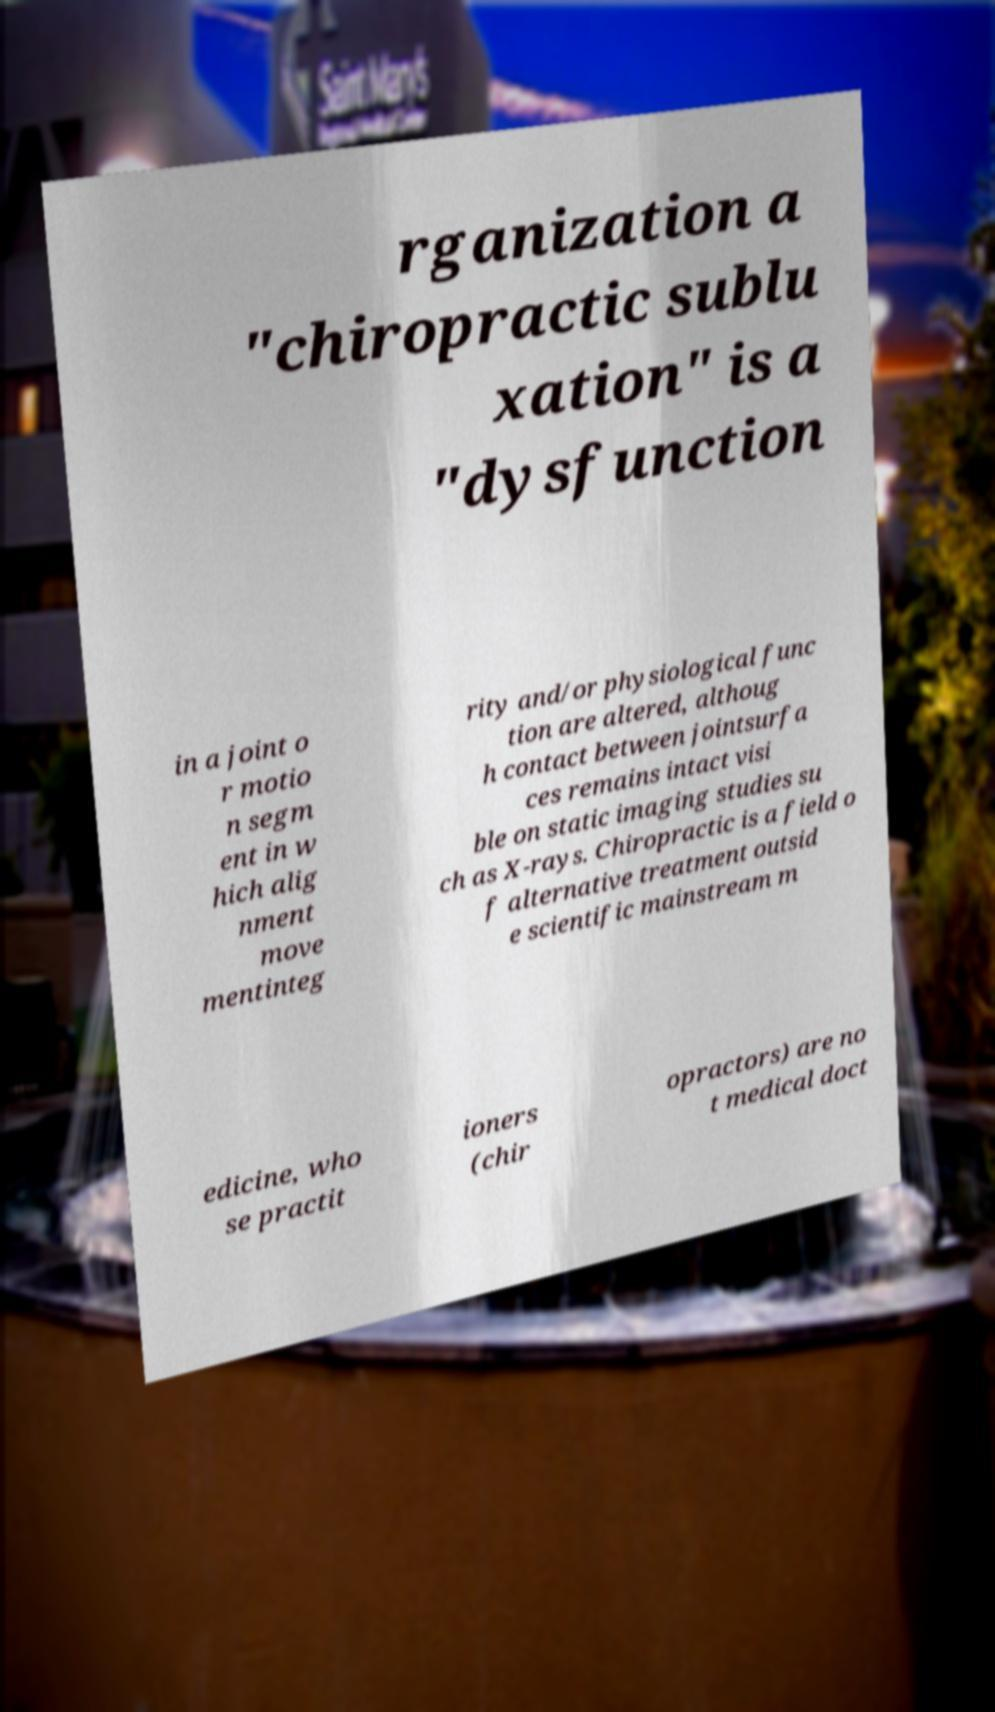Can you read and provide the text displayed in the image?This photo seems to have some interesting text. Can you extract and type it out for me? rganization a "chiropractic sublu xation" is a "dysfunction in a joint o r motio n segm ent in w hich alig nment move mentinteg rity and/or physiological func tion are altered, althoug h contact between jointsurfa ces remains intact visi ble on static imaging studies su ch as X-rays. Chiropractic is a field o f alternative treatment outsid e scientific mainstream m edicine, who se practit ioners (chir opractors) are no t medical doct 